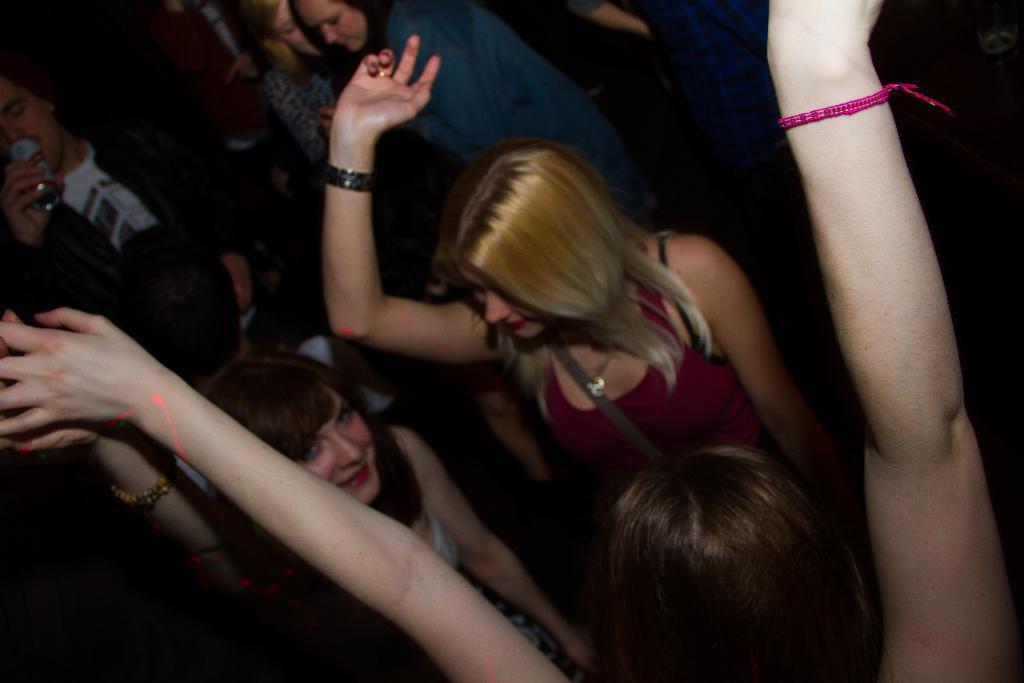Can you describe this image briefly? In this image we can see there are few people dancing with a smile on their face. 